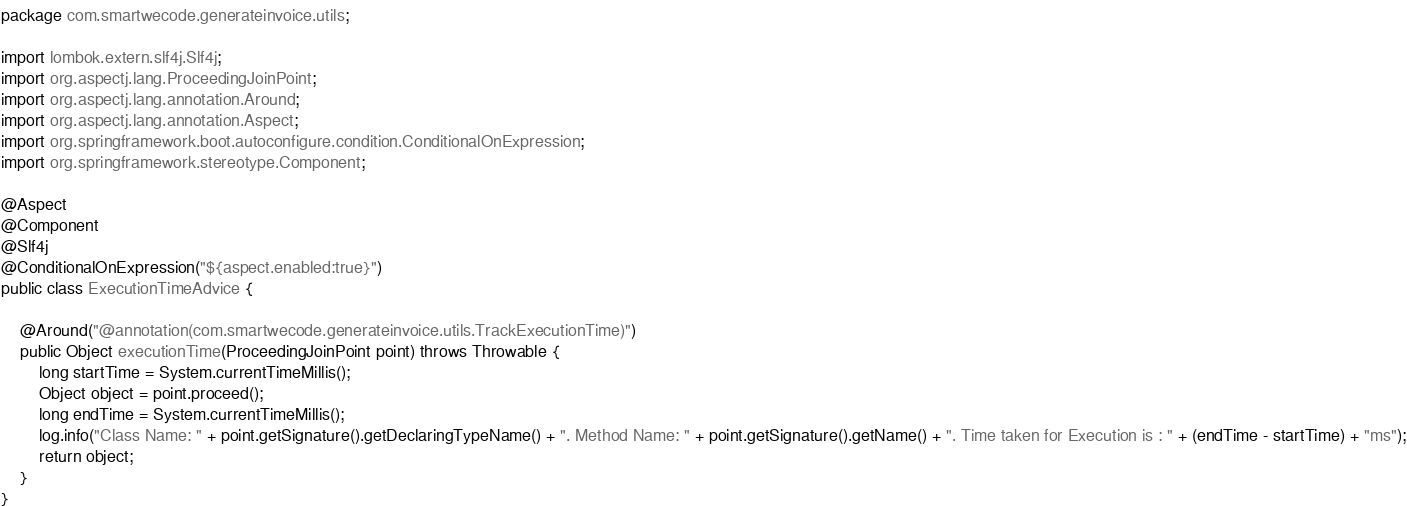<code> <loc_0><loc_0><loc_500><loc_500><_Java_>package com.smartwecode.generateinvoice.utils;

import lombok.extern.slf4j.Slf4j;
import org.aspectj.lang.ProceedingJoinPoint;
import org.aspectj.lang.annotation.Around;
import org.aspectj.lang.annotation.Aspect;
import org.springframework.boot.autoconfigure.condition.ConditionalOnExpression;
import org.springframework.stereotype.Component;

@Aspect
@Component
@Slf4j
@ConditionalOnExpression("${aspect.enabled:true}")
public class ExecutionTimeAdvice {

    @Around("@annotation(com.smartwecode.generateinvoice.utils.TrackExecutionTime)")
    public Object executionTime(ProceedingJoinPoint point) throws Throwable {
        long startTime = System.currentTimeMillis();
        Object object = point.proceed();
        long endTime = System.currentTimeMillis();
        log.info("Class Name: " + point.getSignature().getDeclaringTypeName() + ". Method Name: " + point.getSignature().getName() + ". Time taken for Execution is : " + (endTime - startTime) + "ms");
        return object;
    }
}</code> 